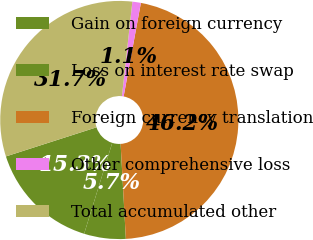<chart> <loc_0><loc_0><loc_500><loc_500><pie_chart><fcel>Gain on foreign currency<fcel>Loss on interest rate swap<fcel>Foreign currency translation<fcel>Other comprehensive loss<fcel>Total accumulated other<nl><fcel>15.28%<fcel>5.65%<fcel>46.22%<fcel>1.15%<fcel>31.7%<nl></chart> 